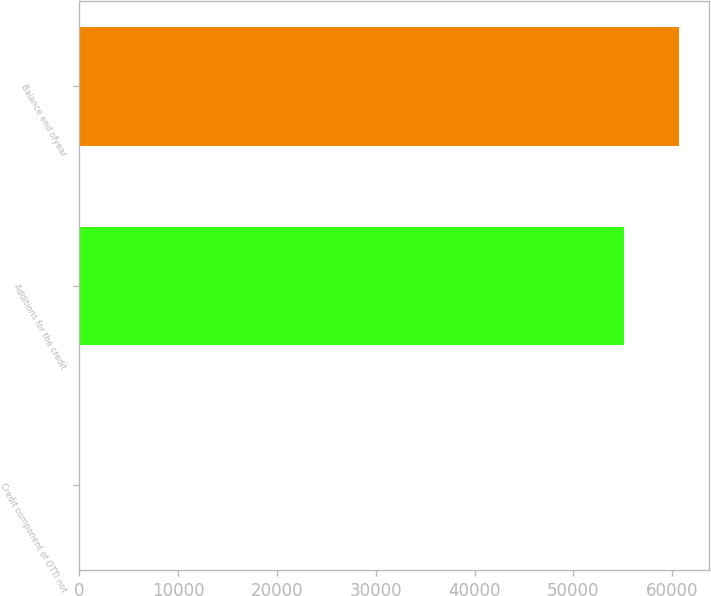Convert chart to OTSL. <chart><loc_0><loc_0><loc_500><loc_500><bar_chart><fcel>Credit component of OTTI not<fcel>Additions for the credit<fcel>Balance end ofyear<nl><fcel>24<fcel>55127<fcel>60639.7<nl></chart> 